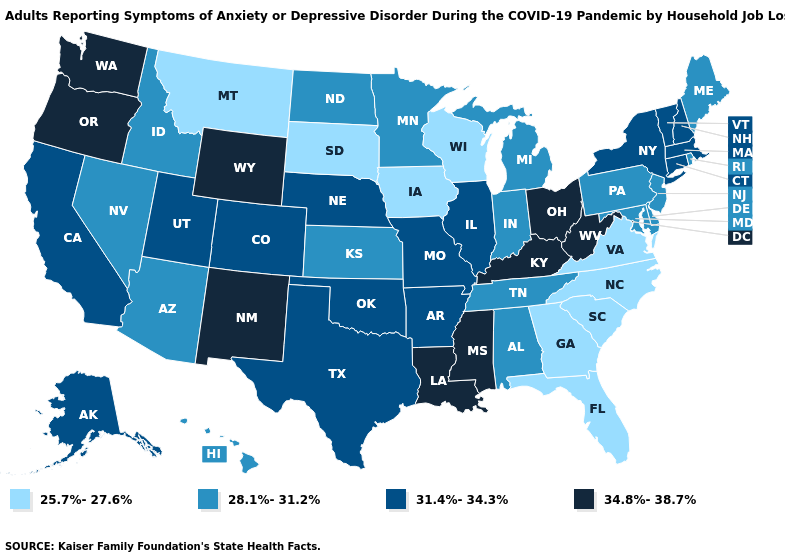What is the lowest value in the West?
Be succinct. 25.7%-27.6%. Among the states that border New York , does Vermont have the lowest value?
Be succinct. No. Name the states that have a value in the range 31.4%-34.3%?
Keep it brief. Alaska, Arkansas, California, Colorado, Connecticut, Illinois, Massachusetts, Missouri, Nebraska, New Hampshire, New York, Oklahoma, Texas, Utah, Vermont. Among the states that border South Dakota , which have the highest value?
Write a very short answer. Wyoming. What is the value of West Virginia?
Short answer required. 34.8%-38.7%. Is the legend a continuous bar?
Be succinct. No. What is the lowest value in the South?
Answer briefly. 25.7%-27.6%. Does Maryland have a lower value than Maine?
Short answer required. No. Does Connecticut have a higher value than Delaware?
Keep it brief. Yes. Does New Hampshire have the highest value in the Northeast?
Keep it brief. Yes. What is the value of New Mexico?
Answer briefly. 34.8%-38.7%. Does Vermont have a higher value than Florida?
Keep it brief. Yes. What is the highest value in states that border South Dakota?
Be succinct. 34.8%-38.7%. Name the states that have a value in the range 34.8%-38.7%?
Concise answer only. Kentucky, Louisiana, Mississippi, New Mexico, Ohio, Oregon, Washington, West Virginia, Wyoming. Among the states that border Iowa , which have the lowest value?
Be succinct. South Dakota, Wisconsin. 